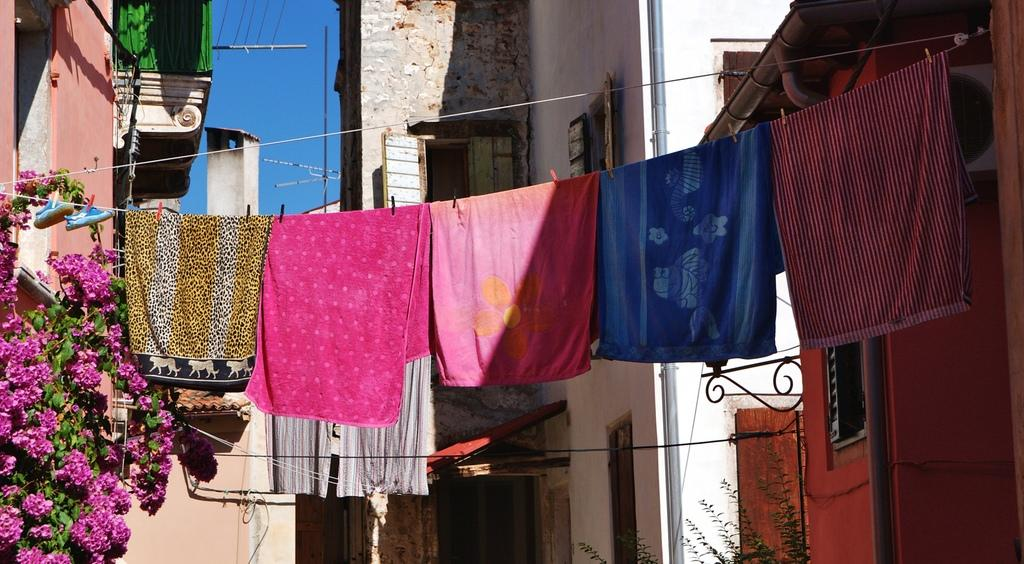What type of structures can be seen in the image? There are buildings in the image. Where are the plants located in the image? There are two plants, one on the left side and one on the right side. What can be seen hanging on the ropes in the image? Clothes hung on ropes are visible in the image. What is the condition of the sky in the image? The sky is clear in the image. What type of lunch is being served by the stranger in the image? There is no stranger or lunch present in the image. How many bushes are visible in the image? There are no bushes visible in the image. 